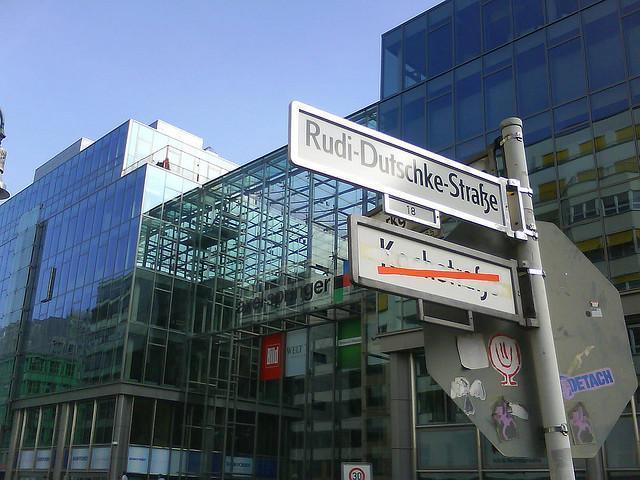How many street signs are pictured?
Give a very brief answer. 3. 